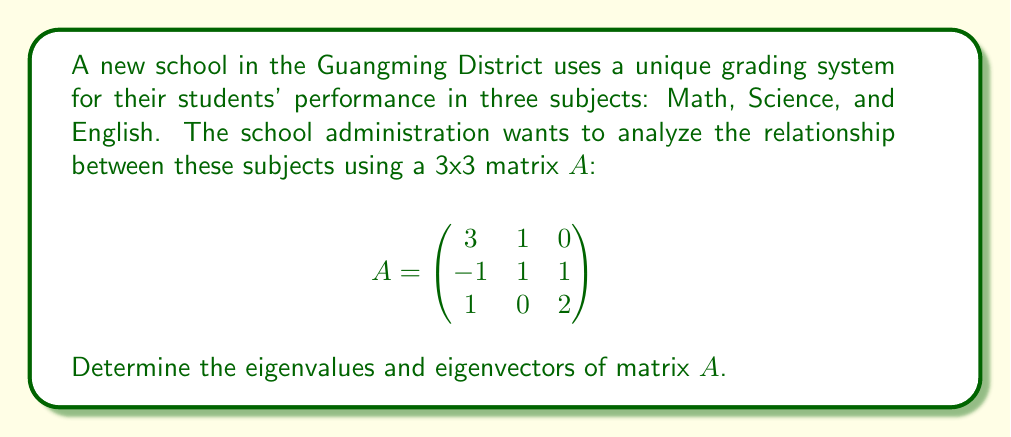Can you solve this math problem? To find the eigenvalues and eigenvectors of matrix $A$, we follow these steps:

1) Find the characteristic equation:
   $det(A - \lambda I) = 0$
   
   $$\begin{vmatrix}
   3-\lambda & 1 & 0 \\
   -1 & 1-\lambda & 1 \\
   1 & 0 & 2-\lambda
   \end{vmatrix} = 0$$

2) Expand the determinant:
   $(3-\lambda)[(1-\lambda)(2-\lambda)-0] - 1[-1(2-\lambda)-1] + 0 = 0$
   $(3-\lambda)(2-3\lambda+\lambda^2) + (2-\lambda+1) = 0$
   $6-9\lambda+3\lambda^2-2\lambda+3\lambda^2-\lambda^3 + 3 = 0$
   $-\lambda^3 + 6\lambda^2 - 11\lambda + 9 = 0$

3) Solve the characteristic equation:
   $(\lambda - 3)(\lambda - 2)(\lambda - 1) = 0$
   
   The eigenvalues are $\lambda_1 = 3$, $\lambda_2 = 2$, and $\lambda_3 = 1$.

4) Find the eigenvectors for each eigenvalue:

   For $\lambda_1 = 3$:
   $(A - 3I)v = 0$
   $$\begin{pmatrix}
   0 & 1 & 0 \\
   -1 & -2 & 1 \\
   1 & 0 & -1
   \end{pmatrix}\begin{pmatrix}
   v_1 \\ v_2 \\ v_3
   \end{pmatrix} = \begin{pmatrix}
   0 \\ 0 \\ 0
   \end{pmatrix}$$
   
   Solving this system gives $v_1 = 1$, $v_2 = 0$, $v_3 = 1$.
   Eigenvector: $v_1 = (1, 0, 1)^T$

   For $\lambda_2 = 2$:
   $(A - 2I)v = 0$
   $$\begin{pmatrix}
   1 & 1 & 0 \\
   -1 & -1 & 1 \\
   1 & 0 & 0
   \end{pmatrix}\begin{pmatrix}
   v_1 \\ v_2 \\ v_3
   \end{pmatrix} = \begin{pmatrix}
   0 \\ 0 \\ 0
   \end{pmatrix}$$
   
   Solving this system gives $v_1 = 1$, $v_2 = -1$, $v_3 = 0$.
   Eigenvector: $v_2 = (1, -1, 0)^T$

   For $\lambda_3 = 1$:
   $(A - I)v = 0$
   $$\begin{pmatrix}
   2 & 1 & 0 \\
   -1 & 0 & 1 \\
   1 & 0 & 1
   \end{pmatrix}\begin{pmatrix}
   v_1 \\ v_2 \\ v_3
   \end{pmatrix} = \begin{pmatrix}
   0 \\ 0 \\ 0
   \end{pmatrix}$$
   
   Solving this system gives $v_1 = 1$, $v_2 = -2$, $v_3 = 1$.
   Eigenvector: $v_3 = (1, -2, 1)^T$
Answer: Eigenvalues: $\lambda_1 = 3$, $\lambda_2 = 2$, $\lambda_3 = 1$
Eigenvectors: $v_1 = (1, 0, 1)^T$, $v_2 = (1, -1, 0)^T$, $v_3 = (1, -2, 1)^T$ 